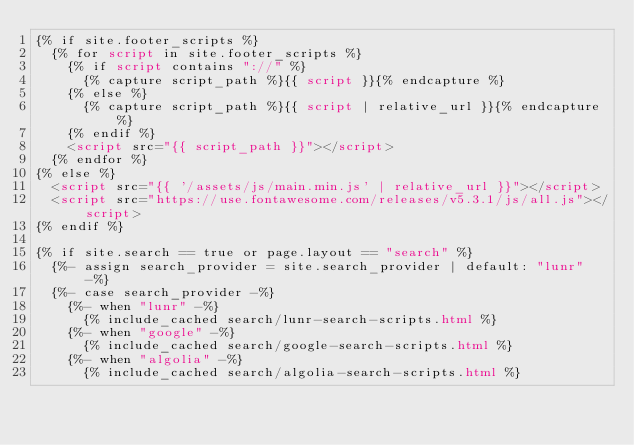<code> <loc_0><loc_0><loc_500><loc_500><_HTML_>{% if site.footer_scripts %}
  {% for script in site.footer_scripts %}
    {% if script contains "://" %}
      {% capture script_path %}{{ script }}{% endcapture %}
    {% else %}
      {% capture script_path %}{{ script | relative_url }}{% endcapture %}
    {% endif %}
    <script src="{{ script_path }}"></script>
  {% endfor %}
{% else %}
  <script src="{{ '/assets/js/main.min.js' | relative_url }}"></script>
  <script src="https://use.fontawesome.com/releases/v5.3.1/js/all.js"></script>
{% endif %}

{% if site.search == true or page.layout == "search" %}
  {%- assign search_provider = site.search_provider | default: "lunr" -%}
  {%- case search_provider -%}
    {%- when "lunr" -%}
      {% include_cached search/lunr-search-scripts.html %}
    {%- when "google" -%}
      {% include_cached search/google-search-scripts.html %}
    {%- when "algolia" -%}
      {% include_cached search/algolia-search-scripts.html %}</code> 